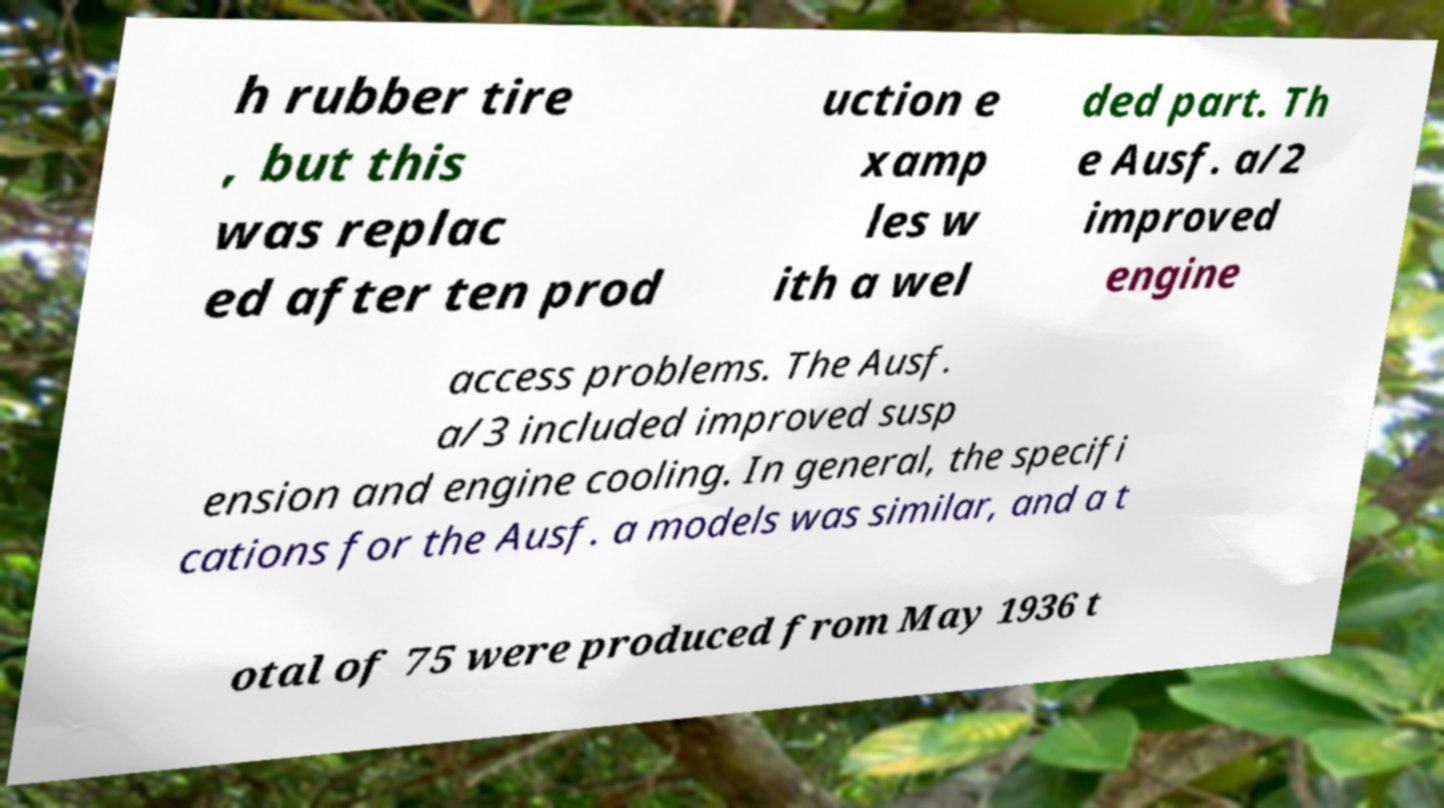Could you assist in decoding the text presented in this image and type it out clearly? h rubber tire , but this was replac ed after ten prod uction e xamp les w ith a wel ded part. Th e Ausf. a/2 improved engine access problems. The Ausf. a/3 included improved susp ension and engine cooling. In general, the specifi cations for the Ausf. a models was similar, and a t otal of 75 were produced from May 1936 t 